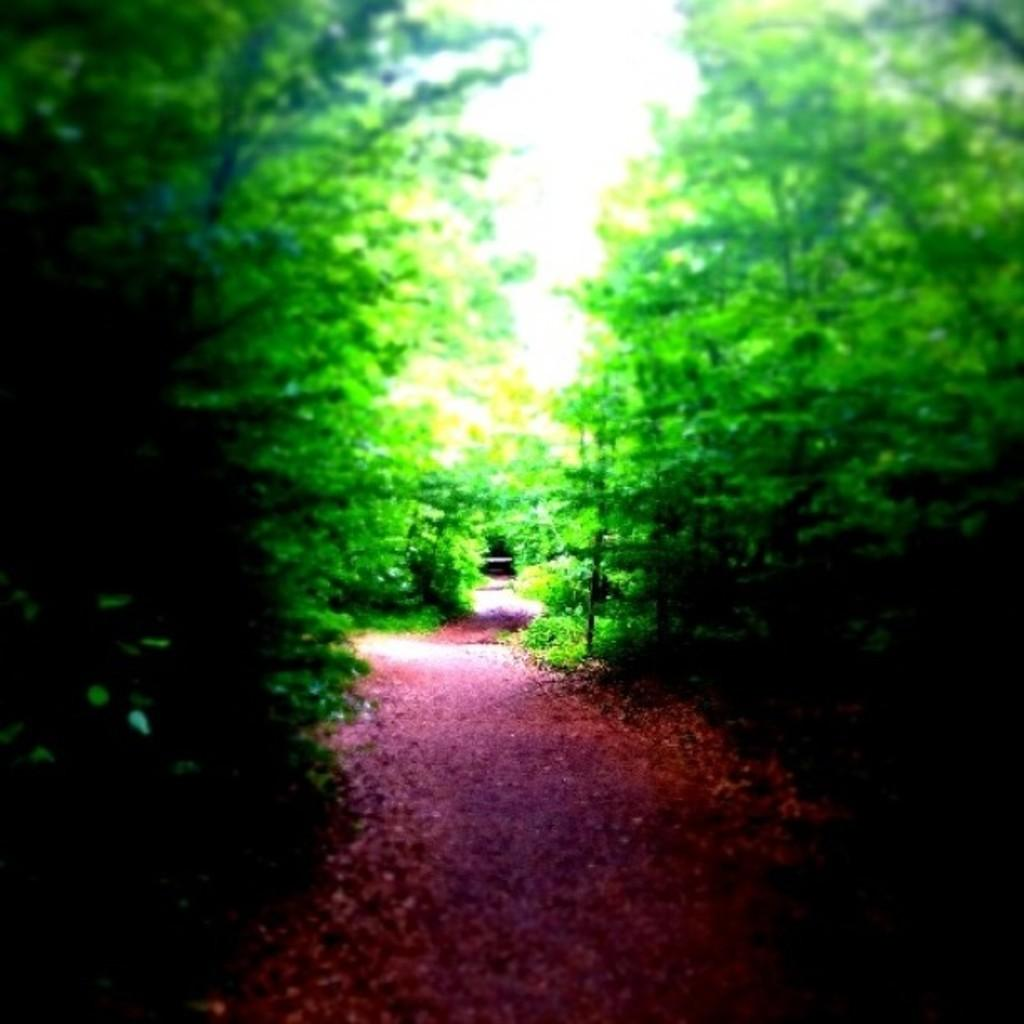What type of vegetation is on the left side of the image? There are trees on the left side of the image. What type of vegetation is on the right side of the image? There are trees on the right side of the image. What can be seen between the trees in the image? There is a walkway between the trees in the image. What type of crime is being committed in the image? There is no indication of any crime being committed in the image; it features trees and a walkway. How does the property in the image contribute to the overall aesthetic? The image does not show any property, only trees and a walkway. 